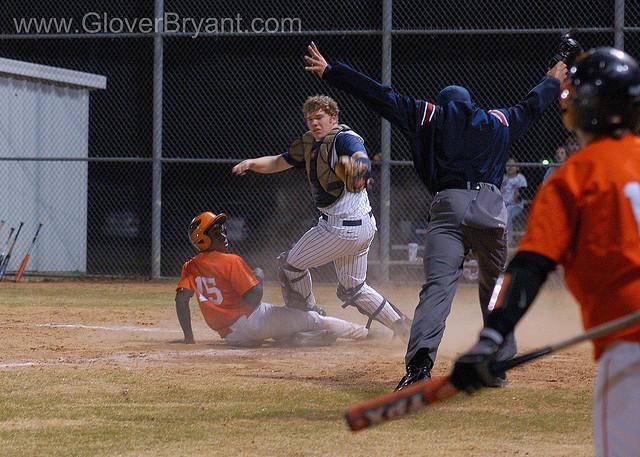How many orange bats are there?
Give a very brief answer. 1. How many players have on orange shirts?
Give a very brief answer. 2. How many people are visible?
Give a very brief answer. 4. How many nails are in the bird feeder?
Give a very brief answer. 0. 